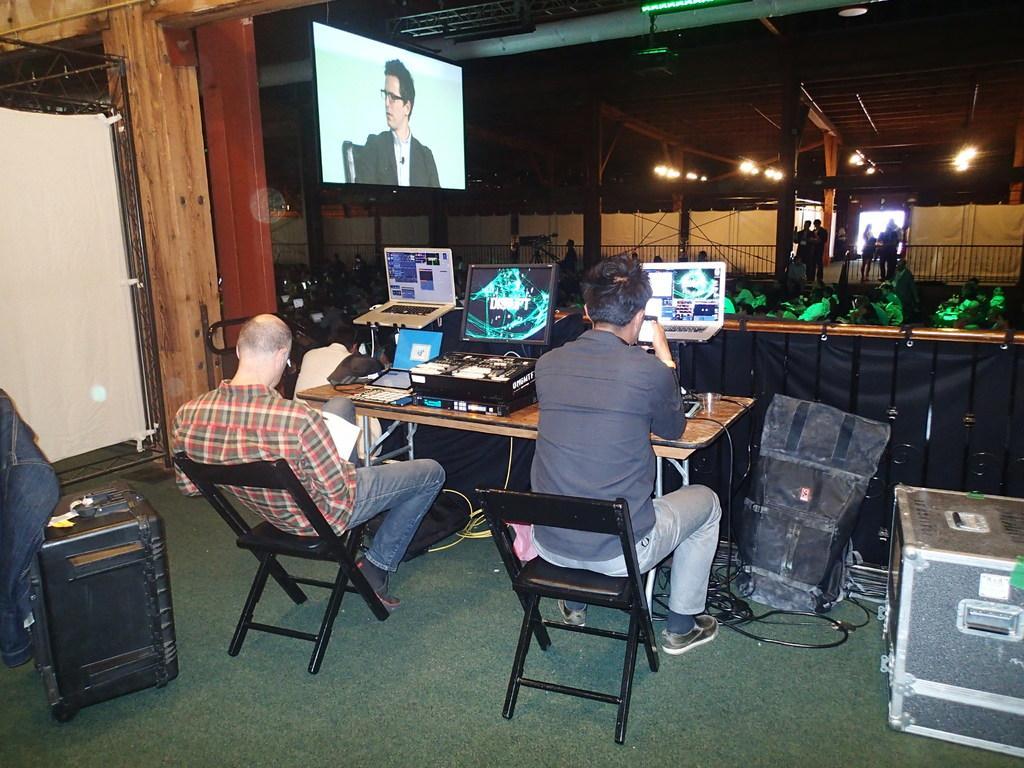How would you summarize this image in a sentence or two? Two persons in this image sitting on the chair in front of them there are laptops and musical instruments and there is a T. V. at the top of the image and at the left side of the image there is a sound box and at the right side of the image there is a box and backpack and at the background there are group of persons and lights 